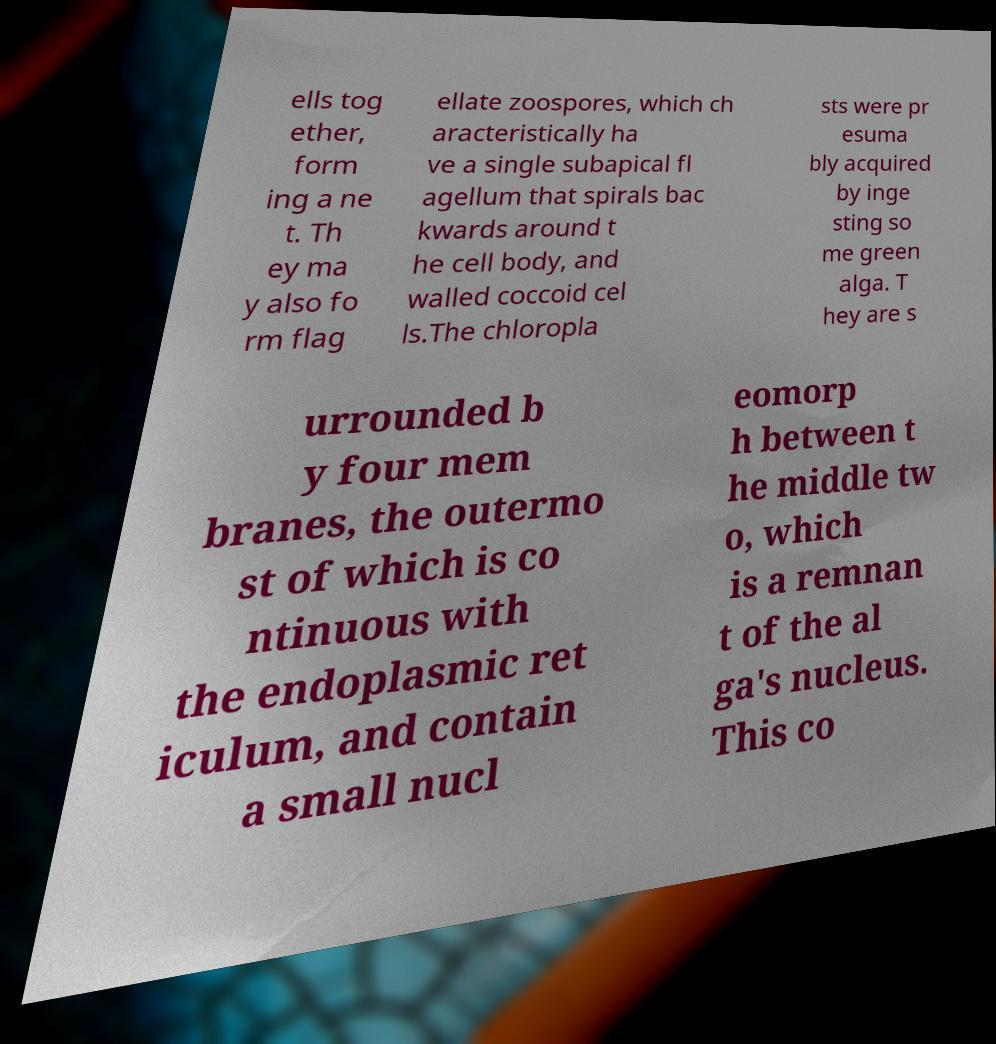For documentation purposes, I need the text within this image transcribed. Could you provide that? ells tog ether, form ing a ne t. Th ey ma y also fo rm flag ellate zoospores, which ch aracteristically ha ve a single subapical fl agellum that spirals bac kwards around t he cell body, and walled coccoid cel ls.The chloropla sts were pr esuma bly acquired by inge sting so me green alga. T hey are s urrounded b y four mem branes, the outermo st of which is co ntinuous with the endoplasmic ret iculum, and contain a small nucl eomorp h between t he middle tw o, which is a remnan t of the al ga's nucleus. This co 